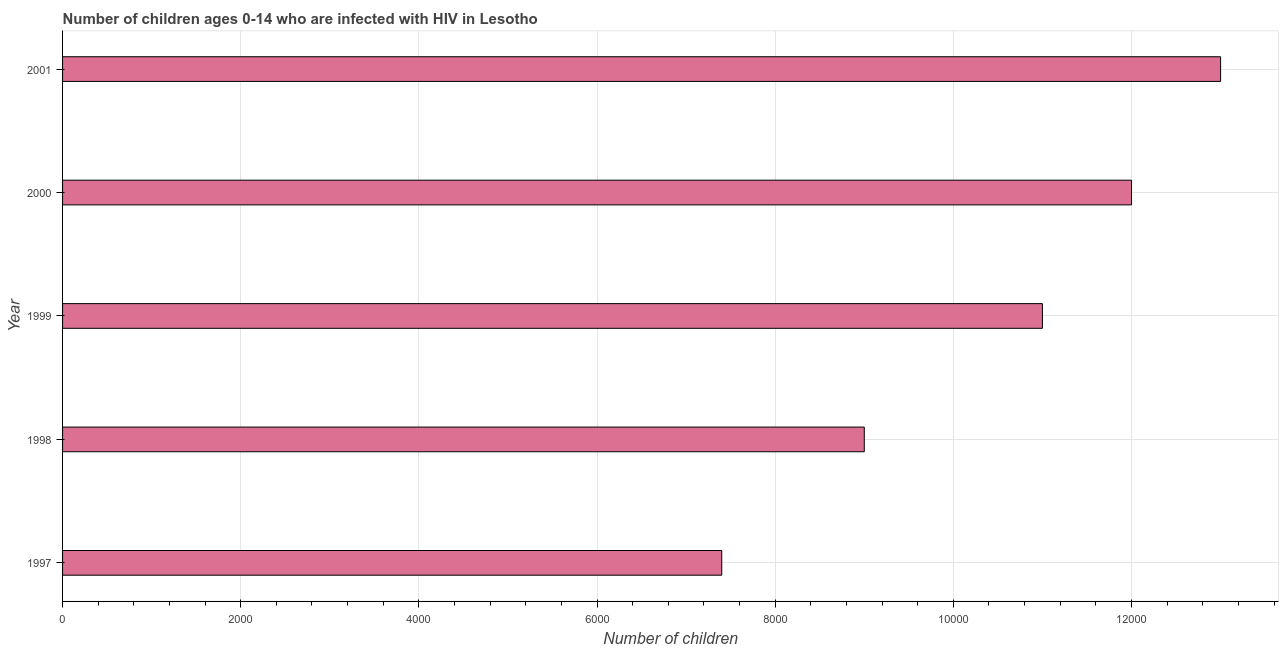Does the graph contain grids?
Your response must be concise. Yes. What is the title of the graph?
Provide a succinct answer. Number of children ages 0-14 who are infected with HIV in Lesotho. What is the label or title of the X-axis?
Offer a very short reply. Number of children. What is the label or title of the Y-axis?
Provide a succinct answer. Year. What is the number of children living with hiv in 1997?
Ensure brevity in your answer.  7400. Across all years, what is the maximum number of children living with hiv?
Offer a terse response. 1.30e+04. Across all years, what is the minimum number of children living with hiv?
Your answer should be compact. 7400. What is the sum of the number of children living with hiv?
Make the answer very short. 5.24e+04. What is the difference between the number of children living with hiv in 1998 and 1999?
Your answer should be very brief. -2000. What is the average number of children living with hiv per year?
Give a very brief answer. 1.05e+04. What is the median number of children living with hiv?
Offer a very short reply. 1.10e+04. Do a majority of the years between 1999 and 1998 (inclusive) have number of children living with hiv greater than 2800 ?
Give a very brief answer. No. What is the ratio of the number of children living with hiv in 1999 to that in 2001?
Ensure brevity in your answer.  0.85. What is the difference between the highest and the second highest number of children living with hiv?
Your answer should be very brief. 1000. What is the difference between the highest and the lowest number of children living with hiv?
Your answer should be compact. 5600. In how many years, is the number of children living with hiv greater than the average number of children living with hiv taken over all years?
Give a very brief answer. 3. How many bars are there?
Your response must be concise. 5. How many years are there in the graph?
Provide a short and direct response. 5. What is the difference between two consecutive major ticks on the X-axis?
Give a very brief answer. 2000. What is the Number of children of 1997?
Your answer should be very brief. 7400. What is the Number of children of 1998?
Your answer should be compact. 9000. What is the Number of children in 1999?
Keep it short and to the point. 1.10e+04. What is the Number of children of 2000?
Your response must be concise. 1.20e+04. What is the Number of children in 2001?
Make the answer very short. 1.30e+04. What is the difference between the Number of children in 1997 and 1998?
Your response must be concise. -1600. What is the difference between the Number of children in 1997 and 1999?
Give a very brief answer. -3600. What is the difference between the Number of children in 1997 and 2000?
Ensure brevity in your answer.  -4600. What is the difference between the Number of children in 1997 and 2001?
Your answer should be very brief. -5600. What is the difference between the Number of children in 1998 and 1999?
Provide a succinct answer. -2000. What is the difference between the Number of children in 1998 and 2000?
Provide a short and direct response. -3000. What is the difference between the Number of children in 1998 and 2001?
Provide a short and direct response. -4000. What is the difference between the Number of children in 1999 and 2000?
Make the answer very short. -1000. What is the difference between the Number of children in 1999 and 2001?
Keep it short and to the point. -2000. What is the difference between the Number of children in 2000 and 2001?
Provide a succinct answer. -1000. What is the ratio of the Number of children in 1997 to that in 1998?
Your answer should be compact. 0.82. What is the ratio of the Number of children in 1997 to that in 1999?
Offer a terse response. 0.67. What is the ratio of the Number of children in 1997 to that in 2000?
Give a very brief answer. 0.62. What is the ratio of the Number of children in 1997 to that in 2001?
Offer a terse response. 0.57. What is the ratio of the Number of children in 1998 to that in 1999?
Your response must be concise. 0.82. What is the ratio of the Number of children in 1998 to that in 2000?
Offer a terse response. 0.75. What is the ratio of the Number of children in 1998 to that in 2001?
Provide a short and direct response. 0.69. What is the ratio of the Number of children in 1999 to that in 2000?
Provide a succinct answer. 0.92. What is the ratio of the Number of children in 1999 to that in 2001?
Offer a very short reply. 0.85. What is the ratio of the Number of children in 2000 to that in 2001?
Offer a terse response. 0.92. 